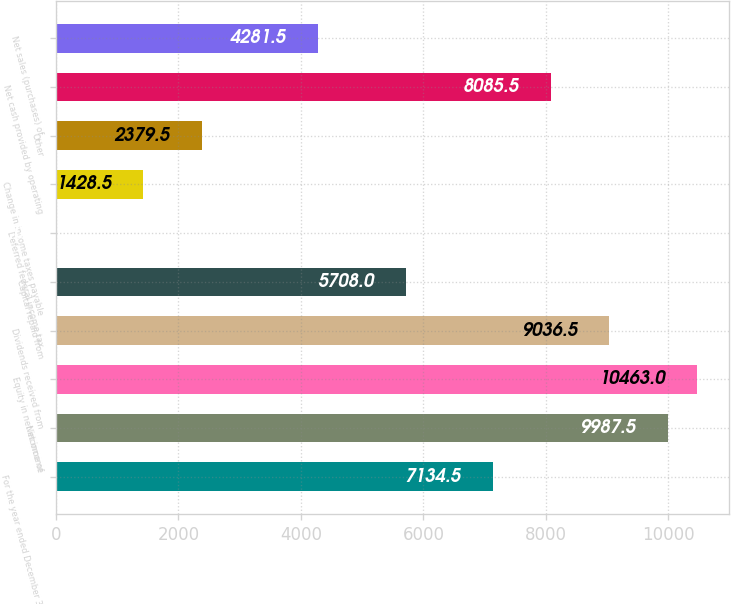Convert chart. <chart><loc_0><loc_0><loc_500><loc_500><bar_chart><fcel>For the year ended December 31<fcel>Net income<fcel>Equity in net income of<fcel>Dividends received from<fcel>Capital repaid from<fcel>Deferred federal income tax<fcel>Change in income taxes payable<fcel>Other<fcel>Net cash provided by operating<fcel>Net sales (purchases) of<nl><fcel>7134.5<fcel>9987.5<fcel>10463<fcel>9036.5<fcel>5708<fcel>2<fcel>1428.5<fcel>2379.5<fcel>8085.5<fcel>4281.5<nl></chart> 